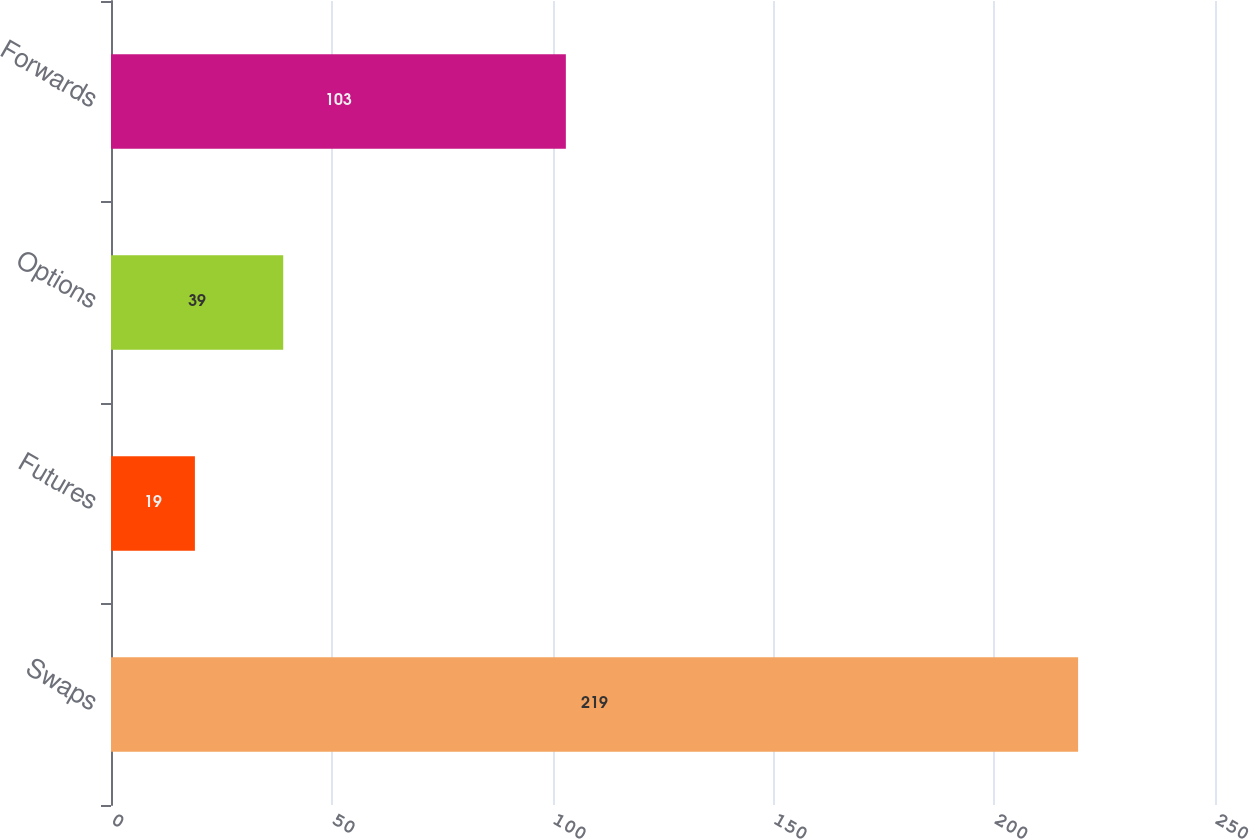Convert chart. <chart><loc_0><loc_0><loc_500><loc_500><bar_chart><fcel>Swaps<fcel>Futures<fcel>Options<fcel>Forwards<nl><fcel>219<fcel>19<fcel>39<fcel>103<nl></chart> 